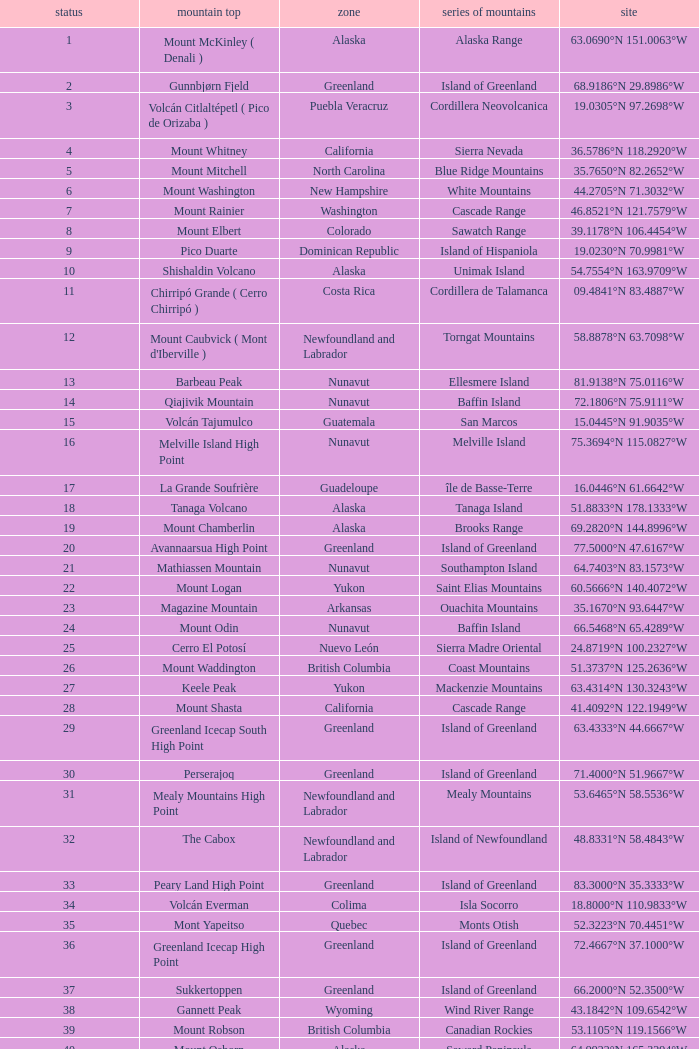Which Mountain Peak has a Region of baja california, and a Location of 28.1301°n 115.2206°w? Isla Cedros High Point. 